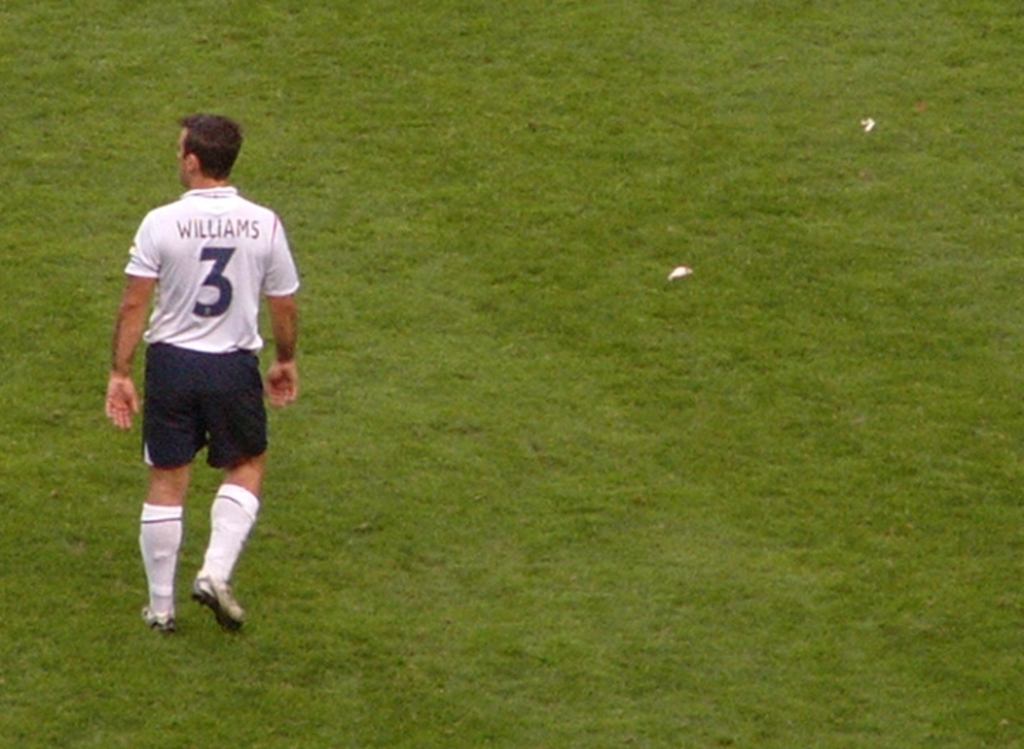Based on this image, can you infer the player's mood or emotions during this moment? The player's posture, walking with his head slightly bowed and isolated from others, might suggest concentration or contemplation, typical for moments of strategizing next moves or reflecting on previous plays during a game. 